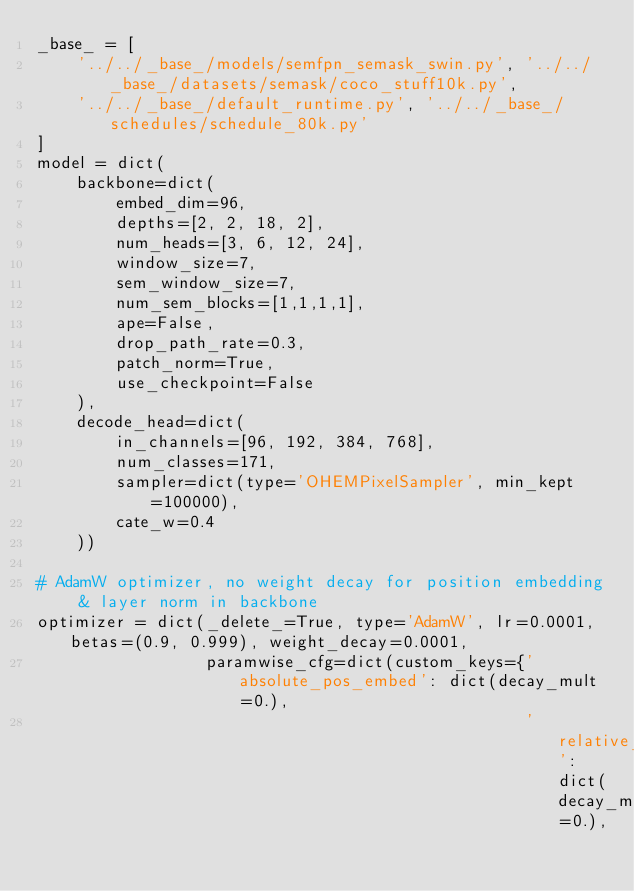<code> <loc_0><loc_0><loc_500><loc_500><_Python_>_base_ = [
    '../../_base_/models/semfpn_semask_swin.py', '../../_base_/datasets/semask/coco_stuff10k.py',
    '../../_base_/default_runtime.py', '../../_base_/schedules/schedule_80k.py'
]
model = dict(
    backbone=dict(
        embed_dim=96,
        depths=[2, 2, 18, 2],
        num_heads=[3, 6, 12, 24],
        window_size=7,
        sem_window_size=7,
        num_sem_blocks=[1,1,1,1],
        ape=False,
        drop_path_rate=0.3,
        patch_norm=True,
        use_checkpoint=False
    ),
    decode_head=dict(
        in_channels=[96, 192, 384, 768],
        num_classes=171,
        sampler=dict(type='OHEMPixelSampler', min_kept=100000),
        cate_w=0.4
    ))

# AdamW optimizer, no weight decay for position embedding & layer norm in backbone
optimizer = dict(_delete_=True, type='AdamW', lr=0.0001, betas=(0.9, 0.999), weight_decay=0.0001,
                 paramwise_cfg=dict(custom_keys={'absolute_pos_embed': dict(decay_mult=0.),
                                                 'relative_position_bias_table': dict(decay_mult=0.),</code> 